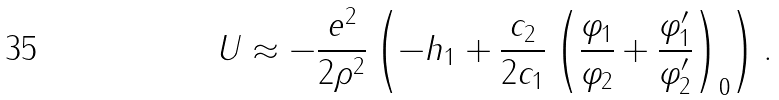<formula> <loc_0><loc_0><loc_500><loc_500>U \approx - \frac { e ^ { 2 } } { 2 \rho ^ { 2 } } \left ( - h _ { 1 } + \frac { c _ { 2 } } { 2 c _ { 1 } } \left ( \frac { \varphi _ { 1 } } { \varphi _ { 2 } } + \frac { \varphi ^ { \prime } _ { 1 } } { \varphi ^ { \prime } _ { 2 } } \right ) _ { 0 } \right ) .</formula> 